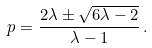Convert formula to latex. <formula><loc_0><loc_0><loc_500><loc_500>p = \frac { 2 \lambda \pm \sqrt { 6 \lambda - 2 } } { \lambda - 1 } \, .</formula> 